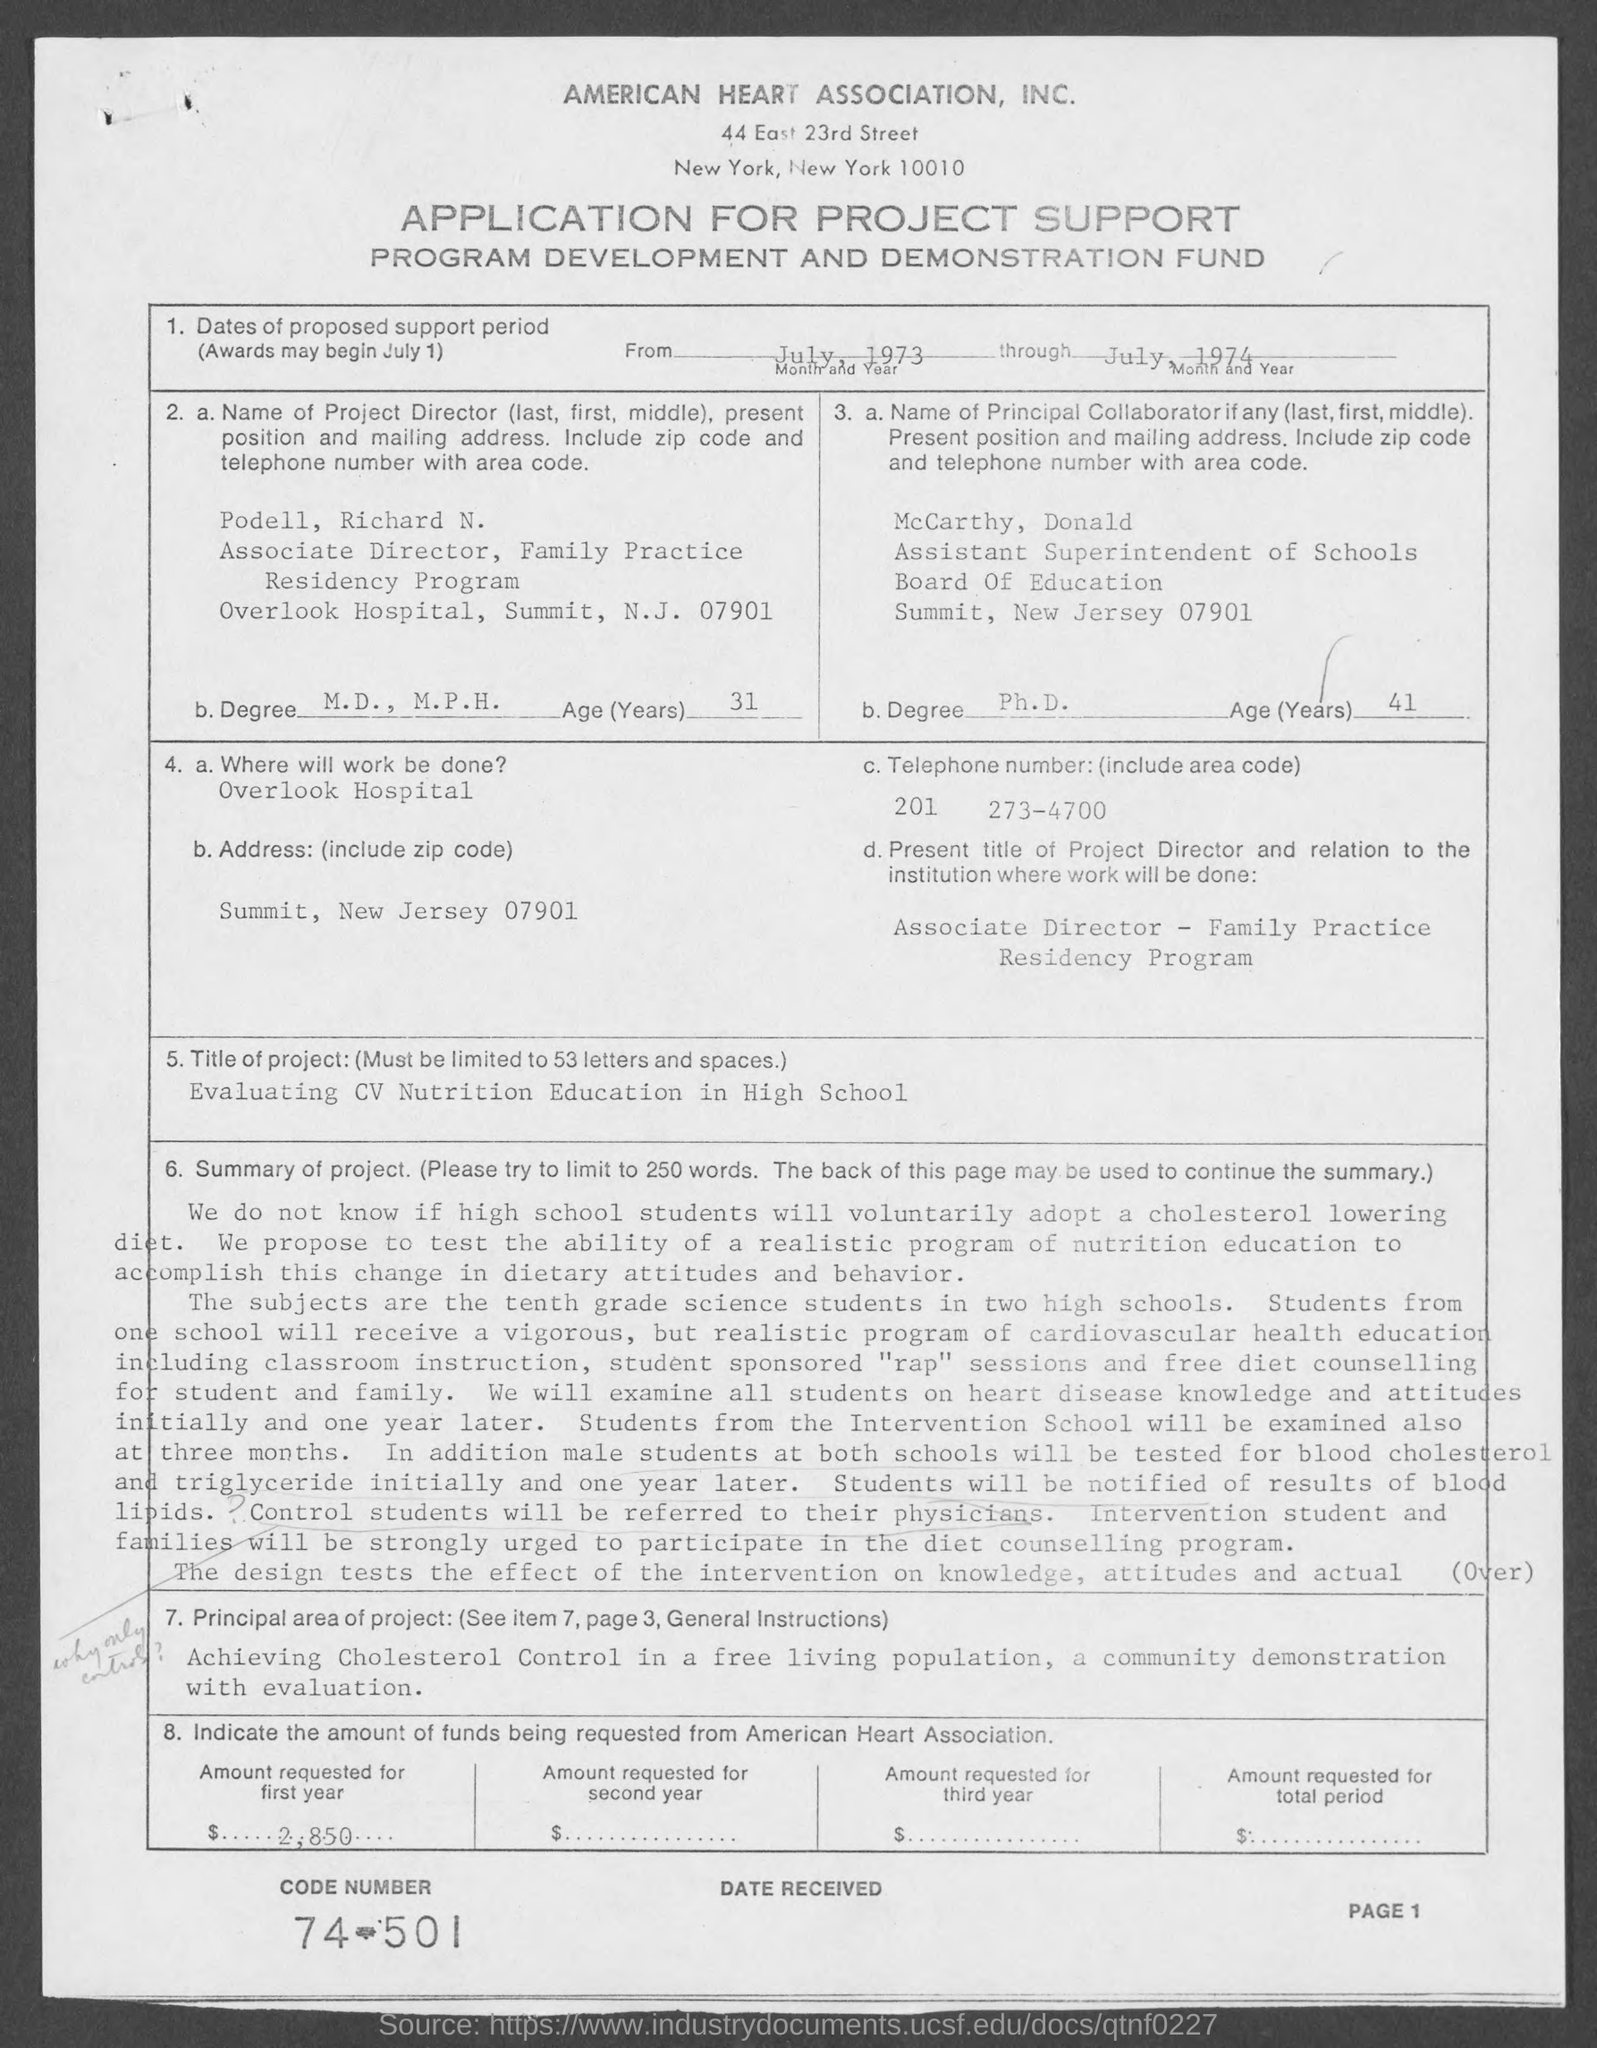Outline some significant characteristics in this image. The principal area of the project mentioned on the given page is the achievement of cholesterol control in a free-living population through a community demonstration and evaluation. The title of the project mentioned in the given page is 'Evaluating CV Nutrition Education in High School.' The telephone number mentioned on the given page is 201 273-4700, including the area code. According to the given page, the age of Podell, Richard N. is 31 years. Please provide the code number listed on the given page, which is 74-501... 